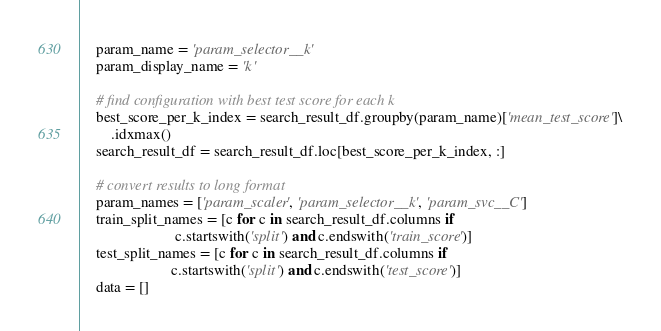<code> <loc_0><loc_0><loc_500><loc_500><_Python_>    param_name = 'param_selector__k'
    param_display_name = 'k'

    # find configuration with best test score for each k
    best_score_per_k_index = search_result_df.groupby(param_name)['mean_test_score']\
        .idxmax()
    search_result_df = search_result_df.loc[best_score_per_k_index, :]

    # convert results to long format
    param_names = ['param_scaler', 'param_selector__k', 'param_svc__C']
    train_split_names = [c for c in search_result_df.columns if
                         c.startswith('split') and c.endswith('train_score')]
    test_split_names = [c for c in search_result_df.columns if
                        c.startswith('split') and c.endswith('test_score')]
    data = []</code> 